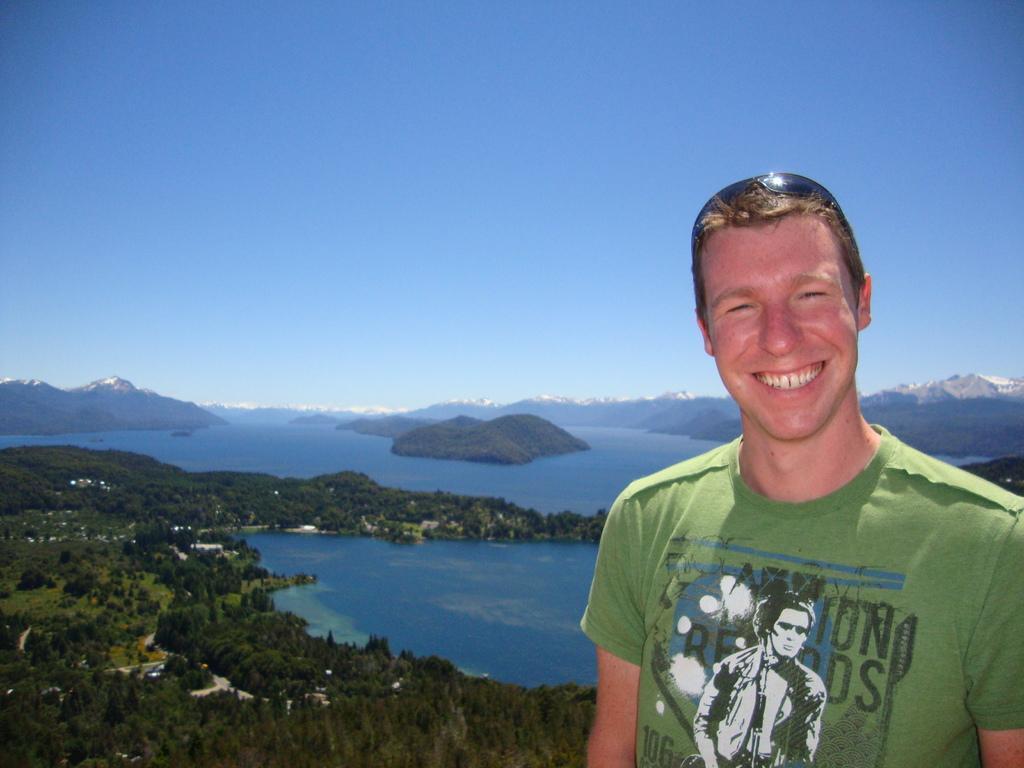How would you summarize this image in a sentence or two? In this image we can see person we can see person, trees, hills, water, mountains and sky. 